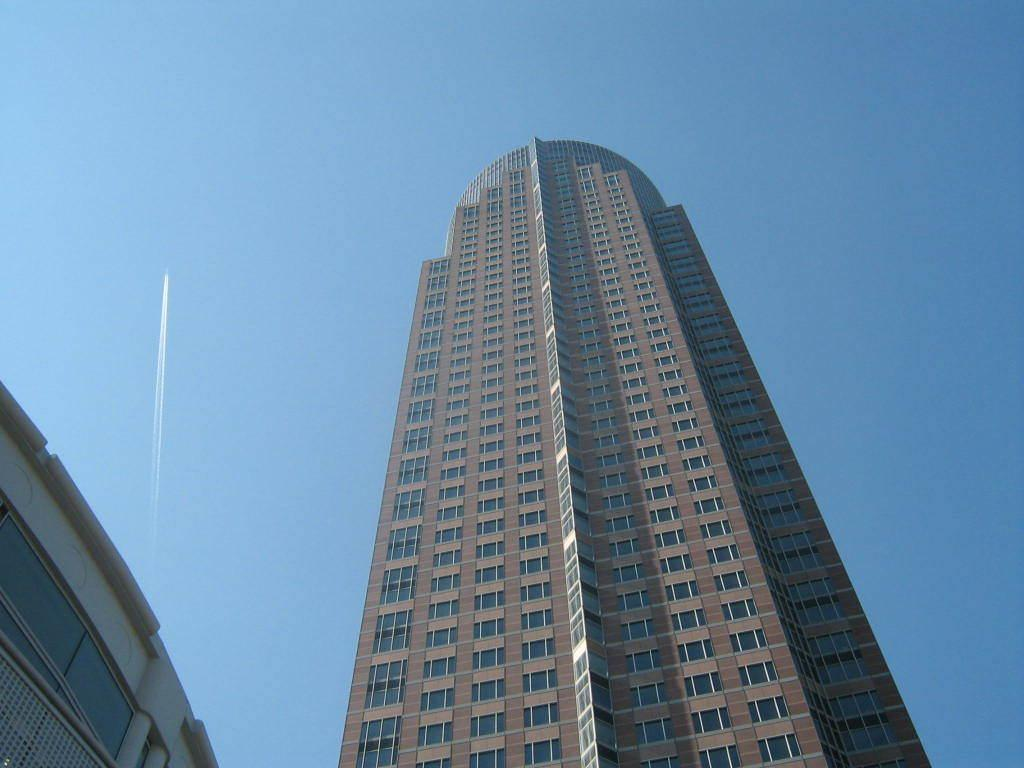What structure is present in the image? There is a building in the image. What feature can be observed on the building? The building has windows. What other subject is visible in the image? There is a jet in the image. What is visible in the background of the image? The sky is visible in the background of the image. What type of space is the yoke used for in the image? There is no yoke present in the image. How many knots are tied on the building in the image? There are no knots tied on the building in the image. 